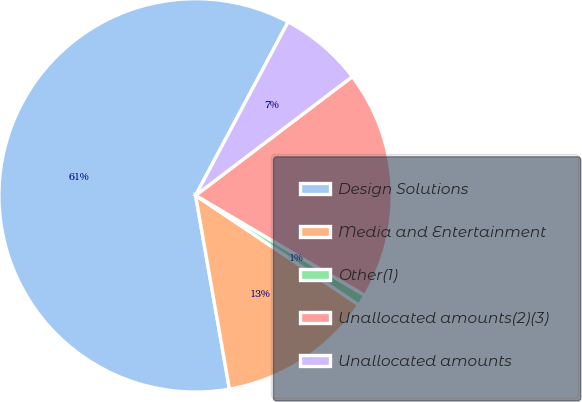Convert chart. <chart><loc_0><loc_0><loc_500><loc_500><pie_chart><fcel>Design Solutions<fcel>Media and Entertainment<fcel>Other(1)<fcel>Unallocated amounts(2)(3)<fcel>Unallocated amounts<nl><fcel>60.55%<fcel>12.84%<fcel>0.92%<fcel>18.81%<fcel>6.88%<nl></chart> 